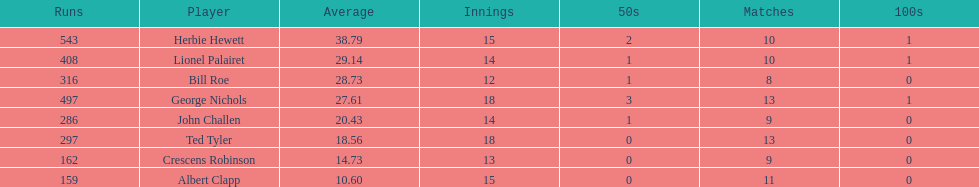How many innings did bill and ted have in total? 30. 